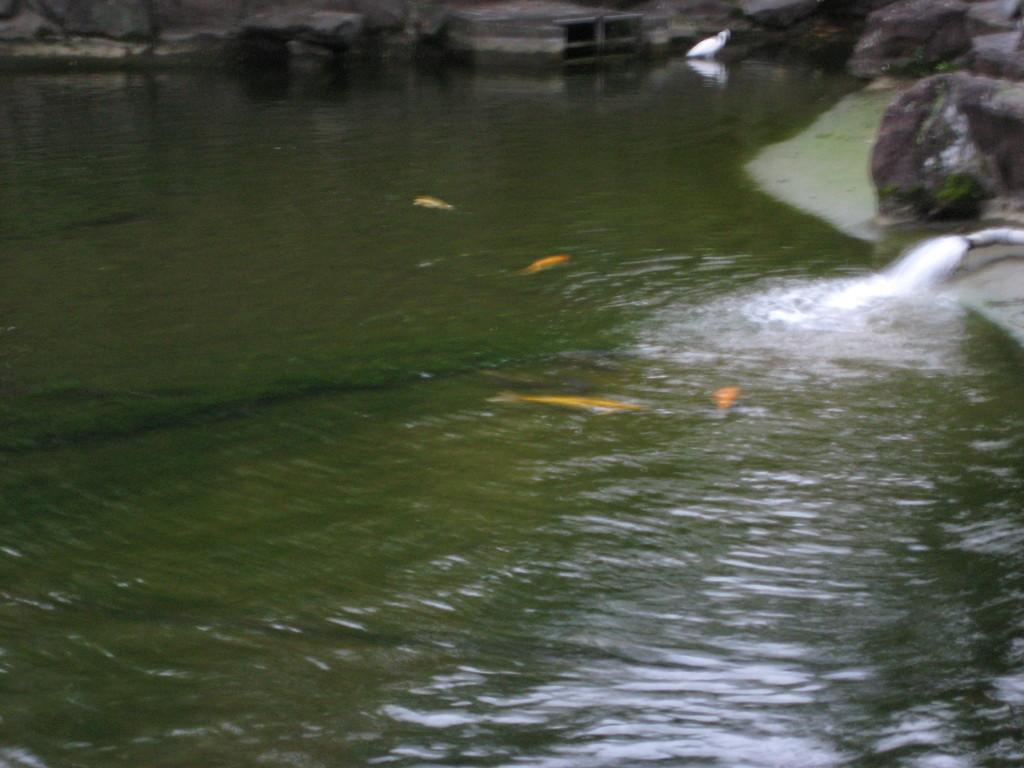What type of animals can be seen in the image? There are fishes in the image. What is the bird doing in the image? The bird is in the water in the image. What can be seen in the background of the image? There are rocks and a pipe in the background of the image. What type of apparel is the fish wearing in the image? There is no apparel present on the fish in the image, as fish do not wear clothing. 